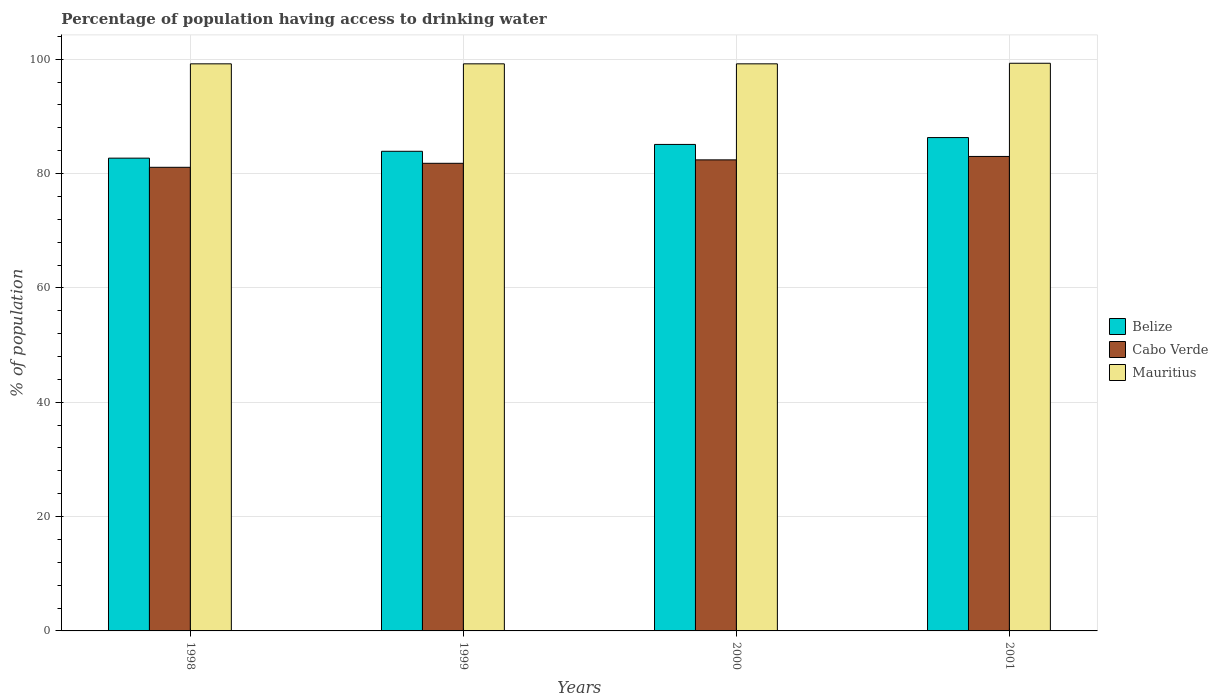How many different coloured bars are there?
Give a very brief answer. 3. Are the number of bars on each tick of the X-axis equal?
Your answer should be compact. Yes. What is the label of the 4th group of bars from the left?
Keep it short and to the point. 2001. In how many cases, is the number of bars for a given year not equal to the number of legend labels?
Make the answer very short. 0. What is the percentage of population having access to drinking water in Mauritius in 1998?
Your answer should be very brief. 99.2. Across all years, what is the maximum percentage of population having access to drinking water in Mauritius?
Provide a succinct answer. 99.3. Across all years, what is the minimum percentage of population having access to drinking water in Belize?
Your response must be concise. 82.7. In which year was the percentage of population having access to drinking water in Cabo Verde minimum?
Your response must be concise. 1998. What is the total percentage of population having access to drinking water in Belize in the graph?
Offer a very short reply. 338. What is the difference between the percentage of population having access to drinking water in Belize in 1998 and that in 2000?
Ensure brevity in your answer.  -2.4. What is the difference between the percentage of population having access to drinking water in Mauritius in 1998 and the percentage of population having access to drinking water in Belize in 1999?
Give a very brief answer. 15.3. What is the average percentage of population having access to drinking water in Cabo Verde per year?
Provide a succinct answer. 82.07. In the year 2001, what is the difference between the percentage of population having access to drinking water in Cabo Verde and percentage of population having access to drinking water in Belize?
Your answer should be compact. -3.3. In how many years, is the percentage of population having access to drinking water in Mauritius greater than 84 %?
Give a very brief answer. 4. What is the ratio of the percentage of population having access to drinking water in Cabo Verde in 1998 to that in 2000?
Give a very brief answer. 0.98. Is the difference between the percentage of population having access to drinking water in Cabo Verde in 2000 and 2001 greater than the difference between the percentage of population having access to drinking water in Belize in 2000 and 2001?
Provide a succinct answer. Yes. What is the difference between the highest and the second highest percentage of population having access to drinking water in Cabo Verde?
Provide a succinct answer. 0.6. What is the difference between the highest and the lowest percentage of population having access to drinking water in Cabo Verde?
Provide a succinct answer. 1.9. In how many years, is the percentage of population having access to drinking water in Cabo Verde greater than the average percentage of population having access to drinking water in Cabo Verde taken over all years?
Your answer should be compact. 2. What does the 1st bar from the left in 2001 represents?
Your answer should be very brief. Belize. What does the 2nd bar from the right in 2000 represents?
Your answer should be compact. Cabo Verde. How many bars are there?
Offer a terse response. 12. Are all the bars in the graph horizontal?
Provide a succinct answer. No. What is the difference between two consecutive major ticks on the Y-axis?
Make the answer very short. 20. Does the graph contain any zero values?
Keep it short and to the point. No. Where does the legend appear in the graph?
Provide a succinct answer. Center right. How are the legend labels stacked?
Offer a very short reply. Vertical. What is the title of the graph?
Provide a succinct answer. Percentage of population having access to drinking water. What is the label or title of the X-axis?
Provide a succinct answer. Years. What is the label or title of the Y-axis?
Offer a terse response. % of population. What is the % of population in Belize in 1998?
Offer a very short reply. 82.7. What is the % of population in Cabo Verde in 1998?
Your answer should be compact. 81.1. What is the % of population of Mauritius in 1998?
Keep it short and to the point. 99.2. What is the % of population of Belize in 1999?
Keep it short and to the point. 83.9. What is the % of population in Cabo Verde in 1999?
Your answer should be compact. 81.8. What is the % of population in Mauritius in 1999?
Your answer should be compact. 99.2. What is the % of population in Belize in 2000?
Offer a terse response. 85.1. What is the % of population in Cabo Verde in 2000?
Make the answer very short. 82.4. What is the % of population of Mauritius in 2000?
Provide a short and direct response. 99.2. What is the % of population in Belize in 2001?
Offer a very short reply. 86.3. What is the % of population of Mauritius in 2001?
Offer a very short reply. 99.3. Across all years, what is the maximum % of population of Belize?
Provide a succinct answer. 86.3. Across all years, what is the maximum % of population of Mauritius?
Provide a succinct answer. 99.3. Across all years, what is the minimum % of population of Belize?
Your answer should be very brief. 82.7. Across all years, what is the minimum % of population of Cabo Verde?
Provide a succinct answer. 81.1. Across all years, what is the minimum % of population in Mauritius?
Give a very brief answer. 99.2. What is the total % of population of Belize in the graph?
Ensure brevity in your answer.  338. What is the total % of population of Cabo Verde in the graph?
Provide a short and direct response. 328.3. What is the total % of population of Mauritius in the graph?
Your answer should be very brief. 396.9. What is the difference between the % of population in Cabo Verde in 1998 and that in 1999?
Provide a short and direct response. -0.7. What is the difference between the % of population in Mauritius in 1998 and that in 1999?
Offer a very short reply. 0. What is the difference between the % of population of Belize in 1998 and that in 2000?
Ensure brevity in your answer.  -2.4. What is the difference between the % of population of Cabo Verde in 1998 and that in 2000?
Provide a succinct answer. -1.3. What is the difference between the % of population of Mauritius in 1998 and that in 2000?
Ensure brevity in your answer.  0. What is the difference between the % of population of Belize in 1998 and that in 2001?
Provide a short and direct response. -3.6. What is the difference between the % of population in Cabo Verde in 1998 and that in 2001?
Your response must be concise. -1.9. What is the difference between the % of population of Mauritius in 1999 and that in 2000?
Keep it short and to the point. 0. What is the difference between the % of population in Cabo Verde in 1999 and that in 2001?
Give a very brief answer. -1.2. What is the difference between the % of population in Mauritius in 1999 and that in 2001?
Your response must be concise. -0.1. What is the difference between the % of population in Cabo Verde in 2000 and that in 2001?
Keep it short and to the point. -0.6. What is the difference between the % of population in Belize in 1998 and the % of population in Mauritius in 1999?
Provide a succinct answer. -16.5. What is the difference between the % of population in Cabo Verde in 1998 and the % of population in Mauritius in 1999?
Your response must be concise. -18.1. What is the difference between the % of population of Belize in 1998 and the % of population of Cabo Verde in 2000?
Provide a succinct answer. 0.3. What is the difference between the % of population in Belize in 1998 and the % of population in Mauritius in 2000?
Keep it short and to the point. -16.5. What is the difference between the % of population in Cabo Verde in 1998 and the % of population in Mauritius in 2000?
Offer a terse response. -18.1. What is the difference between the % of population in Belize in 1998 and the % of population in Cabo Verde in 2001?
Provide a succinct answer. -0.3. What is the difference between the % of population in Belize in 1998 and the % of population in Mauritius in 2001?
Make the answer very short. -16.6. What is the difference between the % of population of Cabo Verde in 1998 and the % of population of Mauritius in 2001?
Your answer should be very brief. -18.2. What is the difference between the % of population in Belize in 1999 and the % of population in Mauritius in 2000?
Provide a short and direct response. -15.3. What is the difference between the % of population in Cabo Verde in 1999 and the % of population in Mauritius in 2000?
Your response must be concise. -17.4. What is the difference between the % of population of Belize in 1999 and the % of population of Mauritius in 2001?
Offer a very short reply. -15.4. What is the difference between the % of population of Cabo Verde in 1999 and the % of population of Mauritius in 2001?
Keep it short and to the point. -17.5. What is the difference between the % of population of Belize in 2000 and the % of population of Cabo Verde in 2001?
Provide a short and direct response. 2.1. What is the difference between the % of population in Cabo Verde in 2000 and the % of population in Mauritius in 2001?
Your response must be concise. -16.9. What is the average % of population of Belize per year?
Your response must be concise. 84.5. What is the average % of population of Cabo Verde per year?
Offer a very short reply. 82.08. What is the average % of population of Mauritius per year?
Keep it short and to the point. 99.22. In the year 1998, what is the difference between the % of population of Belize and % of population of Mauritius?
Your answer should be very brief. -16.5. In the year 1998, what is the difference between the % of population in Cabo Verde and % of population in Mauritius?
Your answer should be very brief. -18.1. In the year 1999, what is the difference between the % of population of Belize and % of population of Cabo Verde?
Provide a succinct answer. 2.1. In the year 1999, what is the difference between the % of population of Belize and % of population of Mauritius?
Your response must be concise. -15.3. In the year 1999, what is the difference between the % of population of Cabo Verde and % of population of Mauritius?
Provide a short and direct response. -17.4. In the year 2000, what is the difference between the % of population of Belize and % of population of Cabo Verde?
Your answer should be very brief. 2.7. In the year 2000, what is the difference between the % of population of Belize and % of population of Mauritius?
Offer a terse response. -14.1. In the year 2000, what is the difference between the % of population of Cabo Verde and % of population of Mauritius?
Give a very brief answer. -16.8. In the year 2001, what is the difference between the % of population in Belize and % of population in Mauritius?
Offer a very short reply. -13. In the year 2001, what is the difference between the % of population in Cabo Verde and % of population in Mauritius?
Your answer should be very brief. -16.3. What is the ratio of the % of population in Belize in 1998 to that in 1999?
Provide a succinct answer. 0.99. What is the ratio of the % of population in Cabo Verde in 1998 to that in 1999?
Your answer should be compact. 0.99. What is the ratio of the % of population of Mauritius in 1998 to that in 1999?
Ensure brevity in your answer.  1. What is the ratio of the % of population in Belize in 1998 to that in 2000?
Your response must be concise. 0.97. What is the ratio of the % of population in Cabo Verde in 1998 to that in 2000?
Your answer should be compact. 0.98. What is the ratio of the % of population of Mauritius in 1998 to that in 2000?
Your response must be concise. 1. What is the ratio of the % of population in Cabo Verde in 1998 to that in 2001?
Your answer should be very brief. 0.98. What is the ratio of the % of population in Mauritius in 1998 to that in 2001?
Give a very brief answer. 1. What is the ratio of the % of population of Belize in 1999 to that in 2000?
Your response must be concise. 0.99. What is the ratio of the % of population in Cabo Verde in 1999 to that in 2000?
Give a very brief answer. 0.99. What is the ratio of the % of population of Mauritius in 1999 to that in 2000?
Your answer should be very brief. 1. What is the ratio of the % of population in Belize in 1999 to that in 2001?
Your answer should be compact. 0.97. What is the ratio of the % of population in Cabo Verde in 1999 to that in 2001?
Make the answer very short. 0.99. What is the ratio of the % of population in Belize in 2000 to that in 2001?
Keep it short and to the point. 0.99. What is the ratio of the % of population of Mauritius in 2000 to that in 2001?
Your answer should be very brief. 1. What is the difference between the highest and the second highest % of population of Belize?
Make the answer very short. 1.2. What is the difference between the highest and the second highest % of population in Mauritius?
Provide a short and direct response. 0.1. What is the difference between the highest and the lowest % of population in Cabo Verde?
Your answer should be compact. 1.9. What is the difference between the highest and the lowest % of population in Mauritius?
Ensure brevity in your answer.  0.1. 